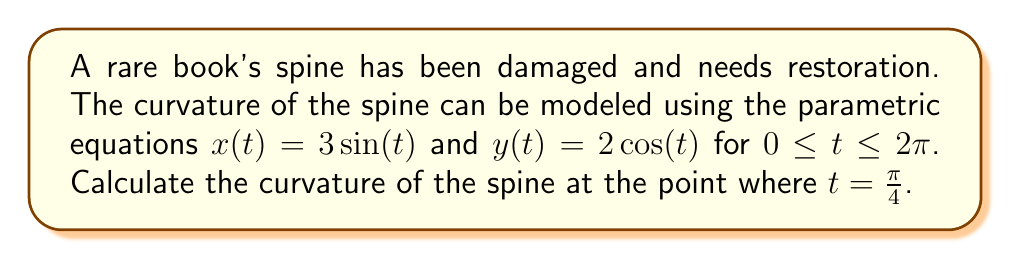Provide a solution to this math problem. To find the curvature of a curve defined by parametric equations, we can use the formula:

$$\kappa = \frac{|x'y'' - y'x''|}{(x'^2 + y'^2)^{3/2}}$$

where $x'$ and $y'$ are the first derivatives, and $x''$ and $y''$ are the second derivatives with respect to $t$.

Step 1: Find the first derivatives
$x'(t) = 3\cos(t)$
$y'(t) = -2\sin(t)$

Step 2: Find the second derivatives
$x''(t) = -3\sin(t)$
$y''(t) = -2\cos(t)$

Step 3: Evaluate the derivatives at $t = \frac{\pi}{4}$
$x'(\frac{\pi}{4}) = 3\cos(\frac{\pi}{4}) = \frac{3\sqrt{2}}{2}$
$y'(\frac{\pi}{4}) = -2\sin(\frac{\pi}{4}) = -\sqrt{2}$
$x''(\frac{\pi}{4}) = -3\sin(\frac{\pi}{4}) = -\frac{3\sqrt{2}}{2}$
$y''(\frac{\pi}{4}) = -2\cos(\frac{\pi}{4}) = -\sqrt{2}$

Step 4: Calculate the numerator of the curvature formula
$|x'y'' - y'x''| = |\frac{3\sqrt{2}}{2}(-\sqrt{2}) - (-\sqrt{2})(-\frac{3\sqrt{2}}{2})|$
$= |-3 - 3| = |-6| = 6$

Step 5: Calculate the denominator of the curvature formula
$(x'^2 + y'^2)^{3/2} = ((\frac{3\sqrt{2}}{2})^2 + (-\sqrt{2})^2)^{3/2}$
$= (\frac{18}{4} + 2)^{3/2} = (\frac{13}{2})^{3/2}$

Step 6: Combine the results to get the curvature
$$\kappa = \frac{6}{(\frac{13}{2})^{3/2}} = \frac{6}{(\frac{13}{2})^{3/2}} \cdot \frac{2^{3/2}}{2^{3/2}} = \frac{12\sqrt{2}}{13\sqrt{13}}$$
Answer: The curvature of the book spine at $t = \frac{\pi}{4}$ is $\frac{12\sqrt{2}}{13\sqrt{13}}$. 